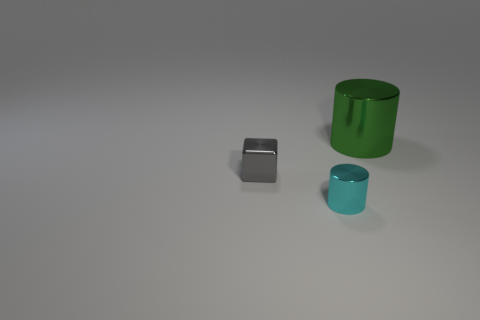Are there fewer tiny cyan things that are behind the large shiny thing than brown cubes?
Give a very brief answer. No. What is the size of the object that is behind the object to the left of the cyan thing?
Provide a short and direct response. Large. How many things are either metallic blocks or cyan shiny cylinders?
Give a very brief answer. 2. Is there a small thing of the same color as the large shiny cylinder?
Provide a succinct answer. No. Are there fewer green things than brown matte objects?
Provide a short and direct response. No. How many objects are either small cyan objects or objects behind the gray shiny thing?
Your response must be concise. 2. Is there a big green thing that has the same material as the cube?
Your answer should be very brief. Yes. What material is the cyan thing that is the same size as the gray block?
Your answer should be very brief. Metal. What material is the cylinder that is in front of the cylinder that is right of the small metallic cylinder made of?
Keep it short and to the point. Metal. There is a shiny object that is in front of the tiny gray shiny block; does it have the same shape as the green shiny thing?
Provide a short and direct response. Yes. 